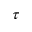<formula> <loc_0><loc_0><loc_500><loc_500>\tau</formula> 